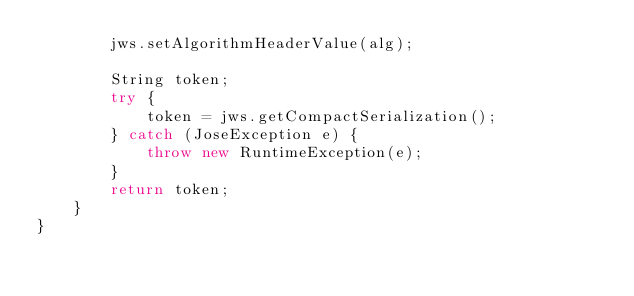<code> <loc_0><loc_0><loc_500><loc_500><_Java_>        jws.setAlgorithmHeaderValue(alg);

        String token;
        try {
            token = jws.getCompactSerialization();
        } catch (JoseException e) {
            throw new RuntimeException(e);
        }
        return token;
    }
}
</code> 